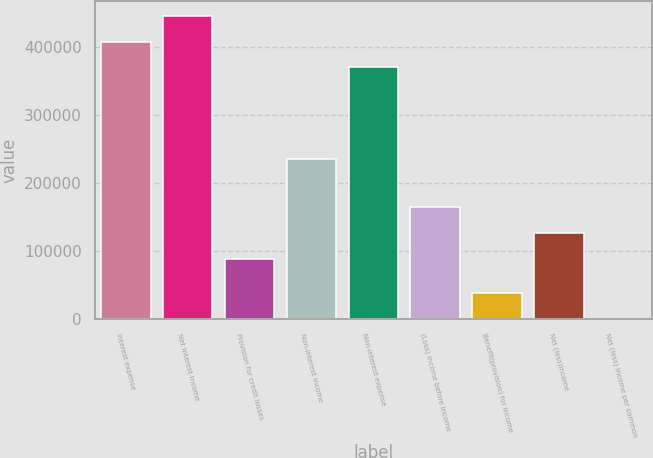Convert chart to OTSL. <chart><loc_0><loc_0><loc_500><loc_500><bar_chart><fcel>Interest expense<fcel>Net interest income<fcel>Provision for credit losses<fcel>Non-interest income<fcel>Non-interest expense<fcel>(Loss) income before income<fcel>Benefit(provision) for income<fcel>Net (loss)income<fcel>Net (loss) income per common<nl><fcel>408163<fcel>445846<fcel>88650<fcel>235752<fcel>370481<fcel>164750<fcel>37682.7<fcel>127068<fcel>0.35<nl></chart> 